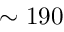<formula> <loc_0><loc_0><loc_500><loc_500>\sim 1 9 0</formula> 